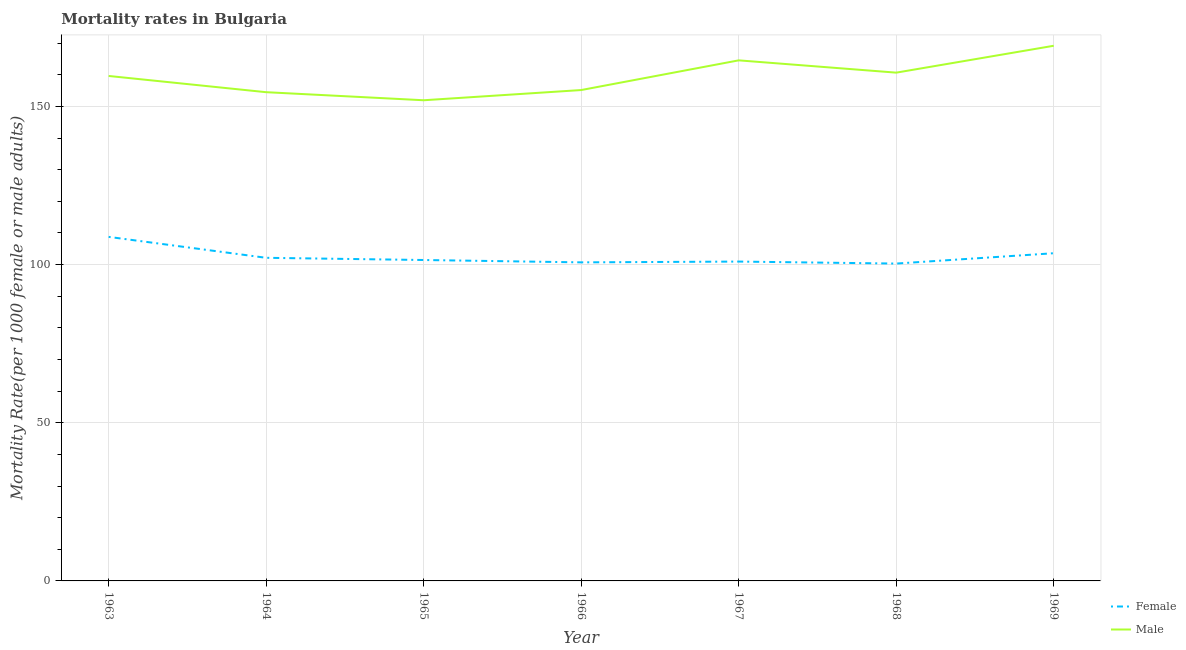Does the line corresponding to female mortality rate intersect with the line corresponding to male mortality rate?
Make the answer very short. No. Is the number of lines equal to the number of legend labels?
Your answer should be very brief. Yes. What is the male mortality rate in 1969?
Your response must be concise. 169.16. Across all years, what is the maximum male mortality rate?
Offer a terse response. 169.16. Across all years, what is the minimum female mortality rate?
Provide a succinct answer. 100.32. In which year was the male mortality rate maximum?
Offer a terse response. 1969. In which year was the female mortality rate minimum?
Your response must be concise. 1968. What is the total female mortality rate in the graph?
Your answer should be very brief. 717.88. What is the difference between the male mortality rate in 1964 and that in 1967?
Give a very brief answer. -10.06. What is the difference between the female mortality rate in 1969 and the male mortality rate in 1968?
Provide a short and direct response. -57.08. What is the average male mortality rate per year?
Provide a short and direct response. 159.37. In the year 1963, what is the difference between the male mortality rate and female mortality rate?
Make the answer very short. 50.87. What is the ratio of the female mortality rate in 1963 to that in 1967?
Your answer should be compact. 1.08. What is the difference between the highest and the second highest male mortality rate?
Your answer should be very brief. 4.61. What is the difference between the highest and the lowest male mortality rate?
Provide a succinct answer. 17.22. Is the sum of the female mortality rate in 1963 and 1968 greater than the maximum male mortality rate across all years?
Provide a short and direct response. Yes. Does the female mortality rate monotonically increase over the years?
Offer a terse response. No. Is the female mortality rate strictly less than the male mortality rate over the years?
Offer a very short reply. Yes. How many lines are there?
Your response must be concise. 2. What is the difference between two consecutive major ticks on the Y-axis?
Your response must be concise. 50. Where does the legend appear in the graph?
Make the answer very short. Bottom right. How many legend labels are there?
Offer a terse response. 2. How are the legend labels stacked?
Provide a succinct answer. Vertical. What is the title of the graph?
Give a very brief answer. Mortality rates in Bulgaria. Does "Food and tobacco" appear as one of the legend labels in the graph?
Provide a short and direct response. No. What is the label or title of the Y-axis?
Your answer should be very brief. Mortality Rate(per 1000 female or male adults). What is the Mortality Rate(per 1000 female or male adults) of Female in 1963?
Keep it short and to the point. 108.75. What is the Mortality Rate(per 1000 female or male adults) in Male in 1963?
Offer a terse response. 159.62. What is the Mortality Rate(per 1000 female or male adults) of Female in 1964?
Keep it short and to the point. 102.14. What is the Mortality Rate(per 1000 female or male adults) of Male in 1964?
Your answer should be compact. 154.49. What is the Mortality Rate(per 1000 female or male adults) in Female in 1965?
Offer a terse response. 101.44. What is the Mortality Rate(per 1000 female or male adults) of Male in 1965?
Offer a very short reply. 151.94. What is the Mortality Rate(per 1000 female or male adults) of Female in 1966?
Offer a very short reply. 100.7. What is the Mortality Rate(per 1000 female or male adults) in Male in 1966?
Ensure brevity in your answer.  155.16. What is the Mortality Rate(per 1000 female or male adults) in Female in 1967?
Provide a succinct answer. 100.95. What is the Mortality Rate(per 1000 female or male adults) in Male in 1967?
Offer a terse response. 164.55. What is the Mortality Rate(per 1000 female or male adults) of Female in 1968?
Offer a very short reply. 100.32. What is the Mortality Rate(per 1000 female or male adults) of Male in 1968?
Give a very brief answer. 160.67. What is the Mortality Rate(per 1000 female or male adults) in Female in 1969?
Your answer should be compact. 103.58. What is the Mortality Rate(per 1000 female or male adults) in Male in 1969?
Offer a terse response. 169.16. Across all years, what is the maximum Mortality Rate(per 1000 female or male adults) of Female?
Your answer should be compact. 108.75. Across all years, what is the maximum Mortality Rate(per 1000 female or male adults) of Male?
Provide a short and direct response. 169.16. Across all years, what is the minimum Mortality Rate(per 1000 female or male adults) of Female?
Provide a succinct answer. 100.32. Across all years, what is the minimum Mortality Rate(per 1000 female or male adults) in Male?
Provide a short and direct response. 151.94. What is the total Mortality Rate(per 1000 female or male adults) of Female in the graph?
Your answer should be compact. 717.88. What is the total Mortality Rate(per 1000 female or male adults) of Male in the graph?
Your answer should be very brief. 1115.6. What is the difference between the Mortality Rate(per 1000 female or male adults) of Female in 1963 and that in 1964?
Ensure brevity in your answer.  6.62. What is the difference between the Mortality Rate(per 1000 female or male adults) in Male in 1963 and that in 1964?
Your answer should be compact. 5.13. What is the difference between the Mortality Rate(per 1000 female or male adults) of Female in 1963 and that in 1965?
Make the answer very short. 7.31. What is the difference between the Mortality Rate(per 1000 female or male adults) in Male in 1963 and that in 1965?
Your answer should be very brief. 7.68. What is the difference between the Mortality Rate(per 1000 female or male adults) of Female in 1963 and that in 1966?
Your answer should be very brief. 8.05. What is the difference between the Mortality Rate(per 1000 female or male adults) of Male in 1963 and that in 1966?
Offer a terse response. 4.45. What is the difference between the Mortality Rate(per 1000 female or male adults) in Female in 1963 and that in 1967?
Your answer should be compact. 7.8. What is the difference between the Mortality Rate(per 1000 female or male adults) of Male in 1963 and that in 1967?
Your answer should be compact. -4.93. What is the difference between the Mortality Rate(per 1000 female or male adults) in Female in 1963 and that in 1968?
Your response must be concise. 8.44. What is the difference between the Mortality Rate(per 1000 female or male adults) of Male in 1963 and that in 1968?
Provide a succinct answer. -1.05. What is the difference between the Mortality Rate(per 1000 female or male adults) of Female in 1963 and that in 1969?
Ensure brevity in your answer.  5.17. What is the difference between the Mortality Rate(per 1000 female or male adults) of Male in 1963 and that in 1969?
Keep it short and to the point. -9.54. What is the difference between the Mortality Rate(per 1000 female or male adults) in Female in 1964 and that in 1965?
Offer a terse response. 0.7. What is the difference between the Mortality Rate(per 1000 female or male adults) in Male in 1964 and that in 1965?
Your answer should be very brief. 2.55. What is the difference between the Mortality Rate(per 1000 female or male adults) of Female in 1964 and that in 1966?
Ensure brevity in your answer.  1.44. What is the difference between the Mortality Rate(per 1000 female or male adults) of Male in 1964 and that in 1966?
Keep it short and to the point. -0.68. What is the difference between the Mortality Rate(per 1000 female or male adults) of Female in 1964 and that in 1967?
Provide a short and direct response. 1.19. What is the difference between the Mortality Rate(per 1000 female or male adults) of Male in 1964 and that in 1967?
Keep it short and to the point. -10.06. What is the difference between the Mortality Rate(per 1000 female or male adults) in Female in 1964 and that in 1968?
Your answer should be very brief. 1.82. What is the difference between the Mortality Rate(per 1000 female or male adults) in Male in 1964 and that in 1968?
Keep it short and to the point. -6.18. What is the difference between the Mortality Rate(per 1000 female or male adults) in Female in 1964 and that in 1969?
Offer a very short reply. -1.45. What is the difference between the Mortality Rate(per 1000 female or male adults) in Male in 1964 and that in 1969?
Offer a very short reply. -14.68. What is the difference between the Mortality Rate(per 1000 female or male adults) in Female in 1965 and that in 1966?
Provide a short and direct response. 0.74. What is the difference between the Mortality Rate(per 1000 female or male adults) of Male in 1965 and that in 1966?
Ensure brevity in your answer.  -3.22. What is the difference between the Mortality Rate(per 1000 female or male adults) in Female in 1965 and that in 1967?
Ensure brevity in your answer.  0.49. What is the difference between the Mortality Rate(per 1000 female or male adults) in Male in 1965 and that in 1967?
Offer a terse response. -12.61. What is the difference between the Mortality Rate(per 1000 female or male adults) of Female in 1965 and that in 1968?
Offer a terse response. 1.12. What is the difference between the Mortality Rate(per 1000 female or male adults) of Male in 1965 and that in 1968?
Your response must be concise. -8.73. What is the difference between the Mortality Rate(per 1000 female or male adults) of Female in 1965 and that in 1969?
Ensure brevity in your answer.  -2.14. What is the difference between the Mortality Rate(per 1000 female or male adults) of Male in 1965 and that in 1969?
Your answer should be compact. -17.22. What is the difference between the Mortality Rate(per 1000 female or male adults) of Male in 1966 and that in 1967?
Keep it short and to the point. -9.39. What is the difference between the Mortality Rate(per 1000 female or male adults) of Female in 1966 and that in 1968?
Your answer should be very brief. 0.38. What is the difference between the Mortality Rate(per 1000 female or male adults) of Male in 1966 and that in 1968?
Offer a very short reply. -5.5. What is the difference between the Mortality Rate(per 1000 female or male adults) in Female in 1966 and that in 1969?
Ensure brevity in your answer.  -2.89. What is the difference between the Mortality Rate(per 1000 female or male adults) in Male in 1966 and that in 1969?
Give a very brief answer. -14. What is the difference between the Mortality Rate(per 1000 female or male adults) in Female in 1967 and that in 1968?
Offer a very short reply. 0.63. What is the difference between the Mortality Rate(per 1000 female or male adults) of Male in 1967 and that in 1968?
Your response must be concise. 3.88. What is the difference between the Mortality Rate(per 1000 female or male adults) of Female in 1967 and that in 1969?
Offer a terse response. -2.64. What is the difference between the Mortality Rate(per 1000 female or male adults) in Male in 1967 and that in 1969?
Your answer should be compact. -4.61. What is the difference between the Mortality Rate(per 1000 female or male adults) of Female in 1968 and that in 1969?
Your answer should be very brief. -3.27. What is the difference between the Mortality Rate(per 1000 female or male adults) of Male in 1968 and that in 1969?
Offer a terse response. -8.49. What is the difference between the Mortality Rate(per 1000 female or male adults) of Female in 1963 and the Mortality Rate(per 1000 female or male adults) of Male in 1964?
Keep it short and to the point. -45.74. What is the difference between the Mortality Rate(per 1000 female or male adults) of Female in 1963 and the Mortality Rate(per 1000 female or male adults) of Male in 1965?
Provide a short and direct response. -43.19. What is the difference between the Mortality Rate(per 1000 female or male adults) of Female in 1963 and the Mortality Rate(per 1000 female or male adults) of Male in 1966?
Offer a very short reply. -46.41. What is the difference between the Mortality Rate(per 1000 female or male adults) in Female in 1963 and the Mortality Rate(per 1000 female or male adults) in Male in 1967?
Provide a succinct answer. -55.8. What is the difference between the Mortality Rate(per 1000 female or male adults) in Female in 1963 and the Mortality Rate(per 1000 female or male adults) in Male in 1968?
Offer a very short reply. -51.92. What is the difference between the Mortality Rate(per 1000 female or male adults) in Female in 1963 and the Mortality Rate(per 1000 female or male adults) in Male in 1969?
Your answer should be very brief. -60.41. What is the difference between the Mortality Rate(per 1000 female or male adults) in Female in 1964 and the Mortality Rate(per 1000 female or male adults) in Male in 1965?
Give a very brief answer. -49.8. What is the difference between the Mortality Rate(per 1000 female or male adults) of Female in 1964 and the Mortality Rate(per 1000 female or male adults) of Male in 1966?
Ensure brevity in your answer.  -53.03. What is the difference between the Mortality Rate(per 1000 female or male adults) in Female in 1964 and the Mortality Rate(per 1000 female or male adults) in Male in 1967?
Your response must be concise. -62.41. What is the difference between the Mortality Rate(per 1000 female or male adults) of Female in 1964 and the Mortality Rate(per 1000 female or male adults) of Male in 1968?
Offer a very short reply. -58.53. What is the difference between the Mortality Rate(per 1000 female or male adults) in Female in 1964 and the Mortality Rate(per 1000 female or male adults) in Male in 1969?
Offer a very short reply. -67.03. What is the difference between the Mortality Rate(per 1000 female or male adults) of Female in 1965 and the Mortality Rate(per 1000 female or male adults) of Male in 1966?
Your response must be concise. -53.72. What is the difference between the Mortality Rate(per 1000 female or male adults) in Female in 1965 and the Mortality Rate(per 1000 female or male adults) in Male in 1967?
Keep it short and to the point. -63.11. What is the difference between the Mortality Rate(per 1000 female or male adults) in Female in 1965 and the Mortality Rate(per 1000 female or male adults) in Male in 1968?
Keep it short and to the point. -59.23. What is the difference between the Mortality Rate(per 1000 female or male adults) in Female in 1965 and the Mortality Rate(per 1000 female or male adults) in Male in 1969?
Provide a succinct answer. -67.72. What is the difference between the Mortality Rate(per 1000 female or male adults) in Female in 1966 and the Mortality Rate(per 1000 female or male adults) in Male in 1967?
Give a very brief answer. -63.85. What is the difference between the Mortality Rate(per 1000 female or male adults) of Female in 1966 and the Mortality Rate(per 1000 female or male adults) of Male in 1968?
Keep it short and to the point. -59.97. What is the difference between the Mortality Rate(per 1000 female or male adults) of Female in 1966 and the Mortality Rate(per 1000 female or male adults) of Male in 1969?
Give a very brief answer. -68.47. What is the difference between the Mortality Rate(per 1000 female or male adults) in Female in 1967 and the Mortality Rate(per 1000 female or male adults) in Male in 1968?
Offer a terse response. -59.72. What is the difference between the Mortality Rate(per 1000 female or male adults) of Female in 1967 and the Mortality Rate(per 1000 female or male adults) of Male in 1969?
Make the answer very short. -68.22. What is the difference between the Mortality Rate(per 1000 female or male adults) of Female in 1968 and the Mortality Rate(per 1000 female or male adults) of Male in 1969?
Your response must be concise. -68.85. What is the average Mortality Rate(per 1000 female or male adults) of Female per year?
Your response must be concise. 102.55. What is the average Mortality Rate(per 1000 female or male adults) in Male per year?
Provide a short and direct response. 159.37. In the year 1963, what is the difference between the Mortality Rate(per 1000 female or male adults) in Female and Mortality Rate(per 1000 female or male adults) in Male?
Your answer should be very brief. -50.87. In the year 1964, what is the difference between the Mortality Rate(per 1000 female or male adults) of Female and Mortality Rate(per 1000 female or male adults) of Male?
Make the answer very short. -52.35. In the year 1965, what is the difference between the Mortality Rate(per 1000 female or male adults) in Female and Mortality Rate(per 1000 female or male adults) in Male?
Provide a short and direct response. -50.5. In the year 1966, what is the difference between the Mortality Rate(per 1000 female or male adults) of Female and Mortality Rate(per 1000 female or male adults) of Male?
Your response must be concise. -54.47. In the year 1967, what is the difference between the Mortality Rate(per 1000 female or male adults) of Female and Mortality Rate(per 1000 female or male adults) of Male?
Your answer should be compact. -63.6. In the year 1968, what is the difference between the Mortality Rate(per 1000 female or male adults) in Female and Mortality Rate(per 1000 female or male adults) in Male?
Your response must be concise. -60.35. In the year 1969, what is the difference between the Mortality Rate(per 1000 female or male adults) in Female and Mortality Rate(per 1000 female or male adults) in Male?
Ensure brevity in your answer.  -65.58. What is the ratio of the Mortality Rate(per 1000 female or male adults) of Female in 1963 to that in 1964?
Your answer should be compact. 1.06. What is the ratio of the Mortality Rate(per 1000 female or male adults) in Male in 1963 to that in 1964?
Your answer should be compact. 1.03. What is the ratio of the Mortality Rate(per 1000 female or male adults) of Female in 1963 to that in 1965?
Your response must be concise. 1.07. What is the ratio of the Mortality Rate(per 1000 female or male adults) of Male in 1963 to that in 1965?
Offer a terse response. 1.05. What is the ratio of the Mortality Rate(per 1000 female or male adults) in Female in 1963 to that in 1966?
Make the answer very short. 1.08. What is the ratio of the Mortality Rate(per 1000 female or male adults) in Male in 1963 to that in 1966?
Provide a short and direct response. 1.03. What is the ratio of the Mortality Rate(per 1000 female or male adults) in Female in 1963 to that in 1967?
Your answer should be compact. 1.08. What is the ratio of the Mortality Rate(per 1000 female or male adults) of Female in 1963 to that in 1968?
Your response must be concise. 1.08. What is the ratio of the Mortality Rate(per 1000 female or male adults) of Male in 1963 to that in 1968?
Offer a very short reply. 0.99. What is the ratio of the Mortality Rate(per 1000 female or male adults) in Female in 1963 to that in 1969?
Your answer should be compact. 1.05. What is the ratio of the Mortality Rate(per 1000 female or male adults) of Male in 1963 to that in 1969?
Your answer should be very brief. 0.94. What is the ratio of the Mortality Rate(per 1000 female or male adults) of Male in 1964 to that in 1965?
Your answer should be very brief. 1.02. What is the ratio of the Mortality Rate(per 1000 female or male adults) in Female in 1964 to that in 1966?
Offer a very short reply. 1.01. What is the ratio of the Mortality Rate(per 1000 female or male adults) in Female in 1964 to that in 1967?
Keep it short and to the point. 1.01. What is the ratio of the Mortality Rate(per 1000 female or male adults) of Male in 1964 to that in 1967?
Make the answer very short. 0.94. What is the ratio of the Mortality Rate(per 1000 female or male adults) of Female in 1964 to that in 1968?
Give a very brief answer. 1.02. What is the ratio of the Mortality Rate(per 1000 female or male adults) in Male in 1964 to that in 1968?
Keep it short and to the point. 0.96. What is the ratio of the Mortality Rate(per 1000 female or male adults) in Male in 1964 to that in 1969?
Provide a short and direct response. 0.91. What is the ratio of the Mortality Rate(per 1000 female or male adults) of Female in 1965 to that in 1966?
Give a very brief answer. 1.01. What is the ratio of the Mortality Rate(per 1000 female or male adults) of Male in 1965 to that in 1966?
Make the answer very short. 0.98. What is the ratio of the Mortality Rate(per 1000 female or male adults) in Female in 1965 to that in 1967?
Offer a terse response. 1. What is the ratio of the Mortality Rate(per 1000 female or male adults) of Male in 1965 to that in 1967?
Ensure brevity in your answer.  0.92. What is the ratio of the Mortality Rate(per 1000 female or male adults) of Female in 1965 to that in 1968?
Give a very brief answer. 1.01. What is the ratio of the Mortality Rate(per 1000 female or male adults) in Male in 1965 to that in 1968?
Provide a succinct answer. 0.95. What is the ratio of the Mortality Rate(per 1000 female or male adults) of Female in 1965 to that in 1969?
Give a very brief answer. 0.98. What is the ratio of the Mortality Rate(per 1000 female or male adults) of Male in 1965 to that in 1969?
Your answer should be compact. 0.9. What is the ratio of the Mortality Rate(per 1000 female or male adults) in Male in 1966 to that in 1967?
Offer a very short reply. 0.94. What is the ratio of the Mortality Rate(per 1000 female or male adults) in Male in 1966 to that in 1968?
Make the answer very short. 0.97. What is the ratio of the Mortality Rate(per 1000 female or male adults) of Female in 1966 to that in 1969?
Make the answer very short. 0.97. What is the ratio of the Mortality Rate(per 1000 female or male adults) in Male in 1966 to that in 1969?
Offer a terse response. 0.92. What is the ratio of the Mortality Rate(per 1000 female or male adults) of Male in 1967 to that in 1968?
Your answer should be compact. 1.02. What is the ratio of the Mortality Rate(per 1000 female or male adults) of Female in 1967 to that in 1969?
Provide a short and direct response. 0.97. What is the ratio of the Mortality Rate(per 1000 female or male adults) of Male in 1967 to that in 1969?
Offer a terse response. 0.97. What is the ratio of the Mortality Rate(per 1000 female or male adults) of Female in 1968 to that in 1969?
Ensure brevity in your answer.  0.97. What is the ratio of the Mortality Rate(per 1000 female or male adults) of Male in 1968 to that in 1969?
Provide a short and direct response. 0.95. What is the difference between the highest and the second highest Mortality Rate(per 1000 female or male adults) in Female?
Offer a terse response. 5.17. What is the difference between the highest and the second highest Mortality Rate(per 1000 female or male adults) in Male?
Your answer should be compact. 4.61. What is the difference between the highest and the lowest Mortality Rate(per 1000 female or male adults) of Female?
Offer a very short reply. 8.44. What is the difference between the highest and the lowest Mortality Rate(per 1000 female or male adults) in Male?
Offer a very short reply. 17.22. 